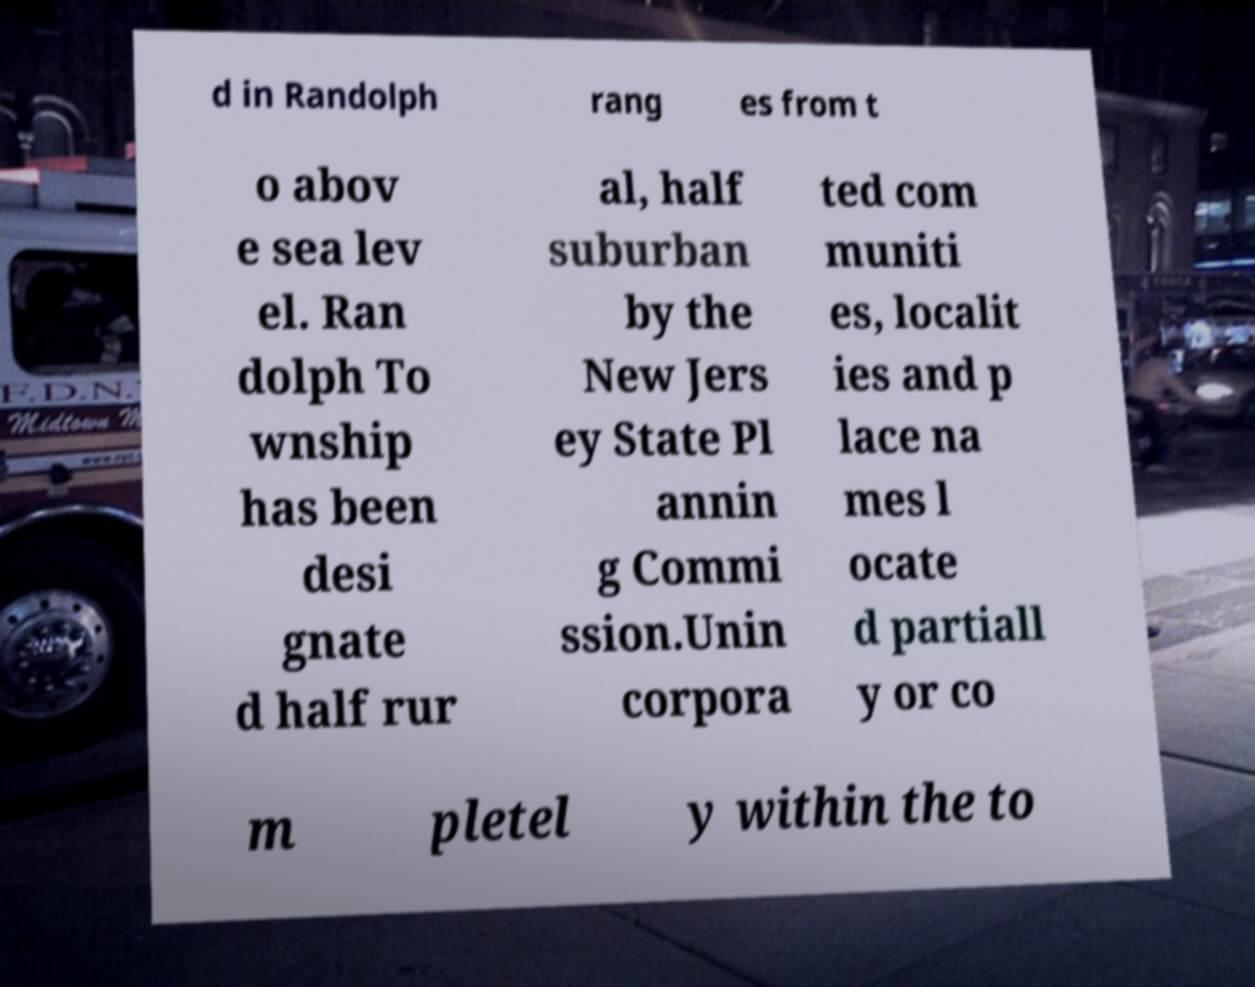Can you read and provide the text displayed in the image?This photo seems to have some interesting text. Can you extract and type it out for me? d in Randolph rang es from t o abov e sea lev el. Ran dolph To wnship has been desi gnate d half rur al, half suburban by the New Jers ey State Pl annin g Commi ssion.Unin corpora ted com muniti es, localit ies and p lace na mes l ocate d partiall y or co m pletel y within the to 